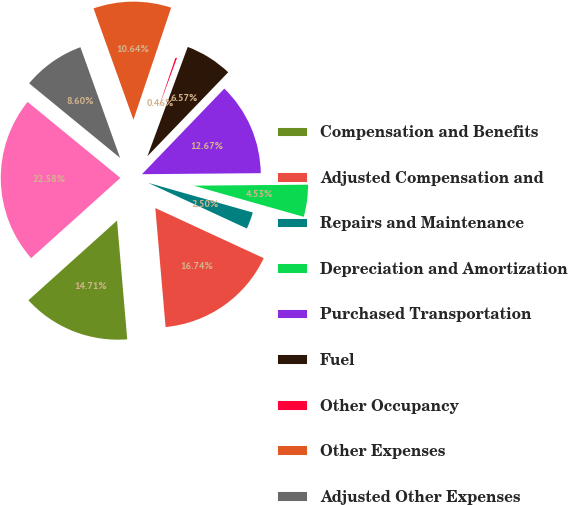Convert chart to OTSL. <chart><loc_0><loc_0><loc_500><loc_500><pie_chart><fcel>Compensation and Benefits<fcel>Adjusted Compensation and<fcel>Repairs and Maintenance<fcel>Depreciation and Amortization<fcel>Purchased Transportation<fcel>Fuel<fcel>Other Occupancy<fcel>Other Expenses<fcel>Adjusted Other Expenses<fcel>Total Operating Expenses<nl><fcel>14.71%<fcel>16.74%<fcel>2.5%<fcel>4.53%<fcel>12.67%<fcel>6.57%<fcel>0.46%<fcel>10.64%<fcel>8.6%<fcel>22.58%<nl></chart> 